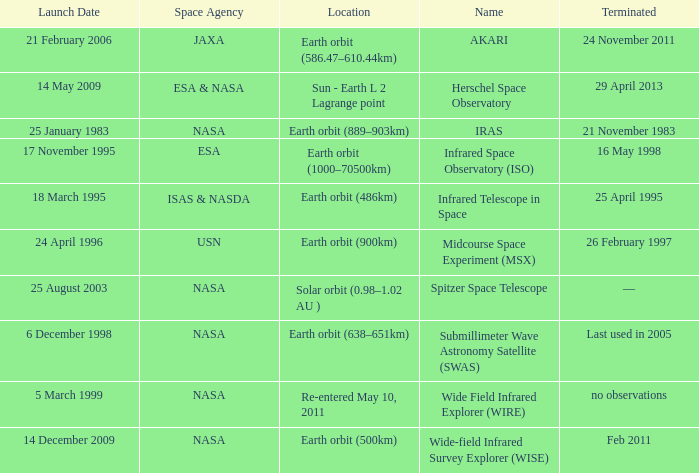When did NASA launch the wide field infrared explorer (wire)? 5 March 1999. 